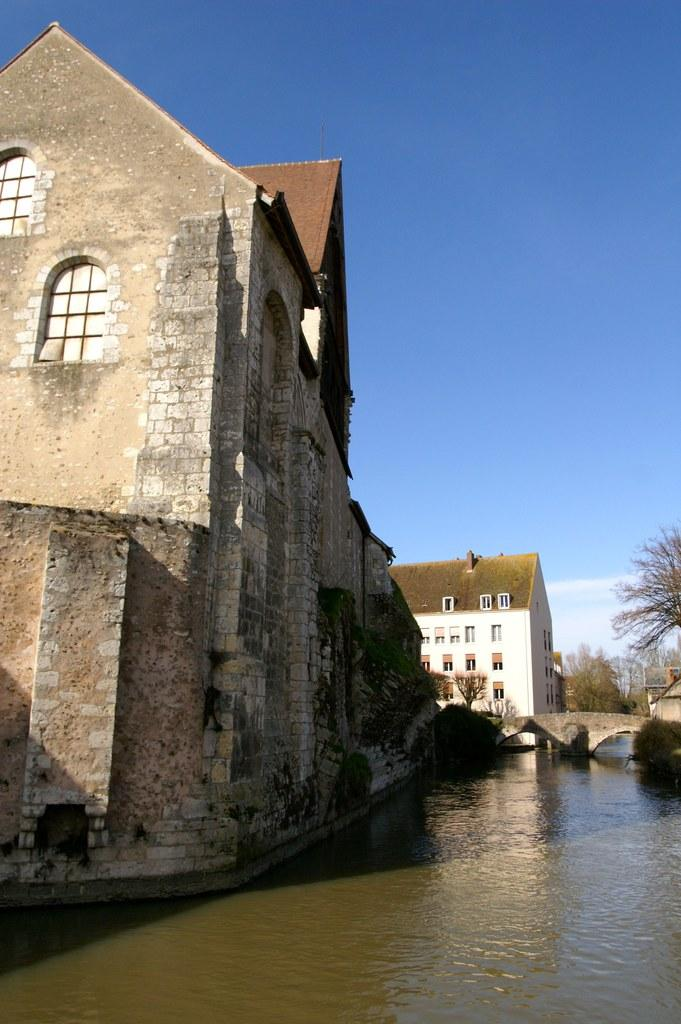What type of structures can be seen in the image? There are buildings in the image. What other natural elements are present in the image? There are trees and water visible in the image. What part of the natural environment is visible in the image? The sky is visible in the image. How many jellyfish can be seen swimming in the water in the image? There are no jellyfish present in the image; it features buildings, trees, water, and the sky. 